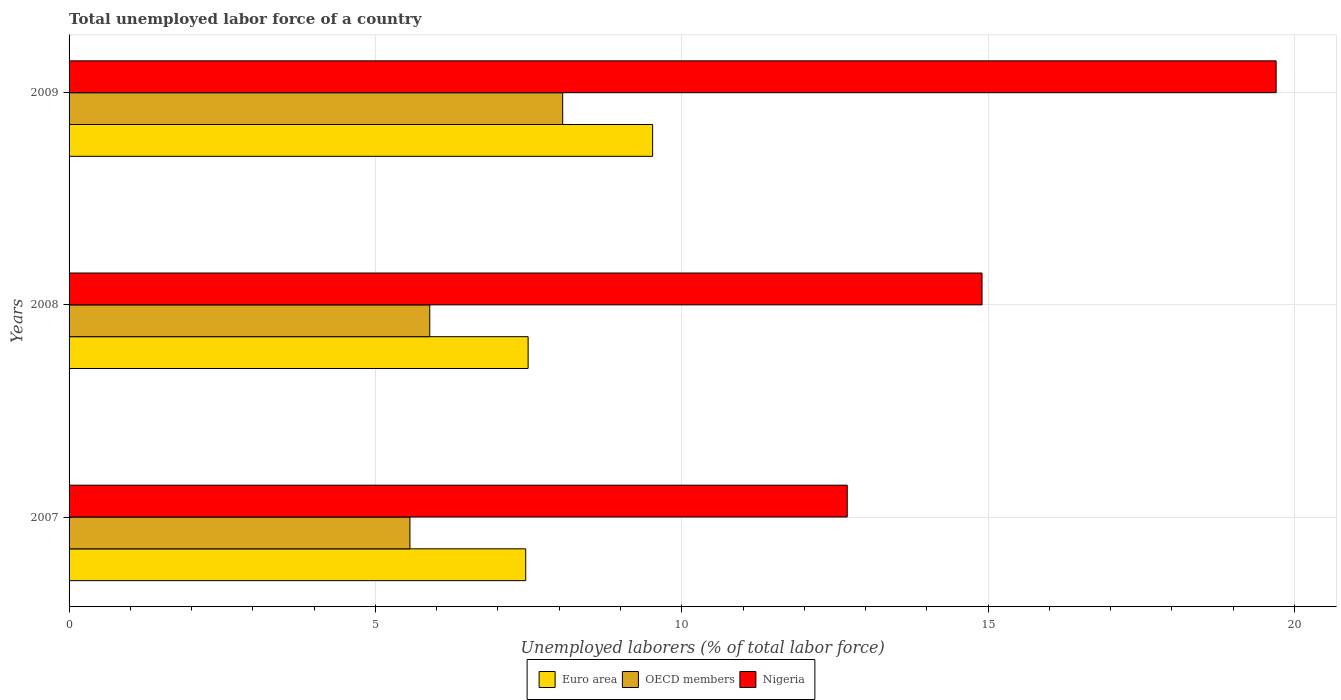How many different coloured bars are there?
Keep it short and to the point. 3. How many groups of bars are there?
Offer a terse response. 3. How many bars are there on the 1st tick from the top?
Your answer should be very brief. 3. How many bars are there on the 1st tick from the bottom?
Give a very brief answer. 3. In how many cases, is the number of bars for a given year not equal to the number of legend labels?
Make the answer very short. 0. What is the total unemployed labor force in OECD members in 2008?
Give a very brief answer. 5.89. Across all years, what is the maximum total unemployed labor force in Euro area?
Offer a very short reply. 9.52. Across all years, what is the minimum total unemployed labor force in OECD members?
Keep it short and to the point. 5.56. What is the total total unemployed labor force in Euro area in the graph?
Your answer should be compact. 24.47. What is the difference between the total unemployed labor force in Nigeria in 2007 and that in 2009?
Your answer should be very brief. -7. What is the difference between the total unemployed labor force in Euro area in 2009 and the total unemployed labor force in OECD members in 2007?
Provide a succinct answer. 3.96. What is the average total unemployed labor force in Nigeria per year?
Your answer should be very brief. 15.77. In the year 2007, what is the difference between the total unemployed labor force in Nigeria and total unemployed labor force in OECD members?
Your answer should be compact. 7.14. What is the ratio of the total unemployed labor force in OECD members in 2008 to that in 2009?
Keep it short and to the point. 0.73. Is the difference between the total unemployed labor force in Nigeria in 2007 and 2009 greater than the difference between the total unemployed labor force in OECD members in 2007 and 2009?
Provide a succinct answer. No. What is the difference between the highest and the second highest total unemployed labor force in Euro area?
Your answer should be compact. 2.03. What is the difference between the highest and the lowest total unemployed labor force in OECD members?
Ensure brevity in your answer.  2.49. In how many years, is the total unemployed labor force in Euro area greater than the average total unemployed labor force in Euro area taken over all years?
Provide a succinct answer. 1. What does the 1st bar from the top in 2007 represents?
Your answer should be very brief. Nigeria. What does the 2nd bar from the bottom in 2009 represents?
Provide a succinct answer. OECD members. How many bars are there?
Keep it short and to the point. 9. Are the values on the major ticks of X-axis written in scientific E-notation?
Provide a short and direct response. No. Does the graph contain any zero values?
Your answer should be very brief. No. Does the graph contain grids?
Offer a terse response. Yes. Where does the legend appear in the graph?
Keep it short and to the point. Bottom center. How many legend labels are there?
Make the answer very short. 3. What is the title of the graph?
Your response must be concise. Total unemployed labor force of a country. Does "Ghana" appear as one of the legend labels in the graph?
Ensure brevity in your answer.  No. What is the label or title of the X-axis?
Make the answer very short. Unemployed laborers (% of total labor force). What is the Unemployed laborers (% of total labor force) of Euro area in 2007?
Offer a terse response. 7.45. What is the Unemployed laborers (% of total labor force) in OECD members in 2007?
Your response must be concise. 5.56. What is the Unemployed laborers (% of total labor force) of Nigeria in 2007?
Provide a succinct answer. 12.7. What is the Unemployed laborers (% of total labor force) of Euro area in 2008?
Make the answer very short. 7.49. What is the Unemployed laborers (% of total labor force) of OECD members in 2008?
Your answer should be very brief. 5.89. What is the Unemployed laborers (% of total labor force) in Nigeria in 2008?
Your answer should be very brief. 14.9. What is the Unemployed laborers (% of total labor force) of Euro area in 2009?
Give a very brief answer. 9.52. What is the Unemployed laborers (% of total labor force) of OECD members in 2009?
Keep it short and to the point. 8.06. What is the Unemployed laborers (% of total labor force) of Nigeria in 2009?
Provide a succinct answer. 19.7. Across all years, what is the maximum Unemployed laborers (% of total labor force) in Euro area?
Keep it short and to the point. 9.52. Across all years, what is the maximum Unemployed laborers (% of total labor force) of OECD members?
Keep it short and to the point. 8.06. Across all years, what is the maximum Unemployed laborers (% of total labor force) of Nigeria?
Offer a very short reply. 19.7. Across all years, what is the minimum Unemployed laborers (% of total labor force) of Euro area?
Offer a very short reply. 7.45. Across all years, what is the minimum Unemployed laborers (% of total labor force) of OECD members?
Provide a short and direct response. 5.56. Across all years, what is the minimum Unemployed laborers (% of total labor force) of Nigeria?
Offer a very short reply. 12.7. What is the total Unemployed laborers (% of total labor force) of Euro area in the graph?
Provide a short and direct response. 24.47. What is the total Unemployed laborers (% of total labor force) in OECD members in the graph?
Your answer should be very brief. 19.51. What is the total Unemployed laborers (% of total labor force) in Nigeria in the graph?
Offer a terse response. 47.3. What is the difference between the Unemployed laborers (% of total labor force) of Euro area in 2007 and that in 2008?
Provide a succinct answer. -0.04. What is the difference between the Unemployed laborers (% of total labor force) of OECD members in 2007 and that in 2008?
Ensure brevity in your answer.  -0.32. What is the difference between the Unemployed laborers (% of total labor force) of Euro area in 2007 and that in 2009?
Give a very brief answer. -2.07. What is the difference between the Unemployed laborers (% of total labor force) of OECD members in 2007 and that in 2009?
Your answer should be very brief. -2.49. What is the difference between the Unemployed laborers (% of total labor force) of Euro area in 2008 and that in 2009?
Ensure brevity in your answer.  -2.03. What is the difference between the Unemployed laborers (% of total labor force) in OECD members in 2008 and that in 2009?
Your answer should be compact. -2.17. What is the difference between the Unemployed laborers (% of total labor force) in Euro area in 2007 and the Unemployed laborers (% of total labor force) in OECD members in 2008?
Your answer should be very brief. 1.57. What is the difference between the Unemployed laborers (% of total labor force) of Euro area in 2007 and the Unemployed laborers (% of total labor force) of Nigeria in 2008?
Keep it short and to the point. -7.45. What is the difference between the Unemployed laborers (% of total labor force) in OECD members in 2007 and the Unemployed laborers (% of total labor force) in Nigeria in 2008?
Your response must be concise. -9.34. What is the difference between the Unemployed laborers (% of total labor force) of Euro area in 2007 and the Unemployed laborers (% of total labor force) of OECD members in 2009?
Provide a short and direct response. -0.6. What is the difference between the Unemployed laborers (% of total labor force) of Euro area in 2007 and the Unemployed laborers (% of total labor force) of Nigeria in 2009?
Provide a succinct answer. -12.25. What is the difference between the Unemployed laborers (% of total labor force) in OECD members in 2007 and the Unemployed laborers (% of total labor force) in Nigeria in 2009?
Offer a terse response. -14.14. What is the difference between the Unemployed laborers (% of total labor force) of Euro area in 2008 and the Unemployed laborers (% of total labor force) of OECD members in 2009?
Make the answer very short. -0.56. What is the difference between the Unemployed laborers (% of total labor force) of Euro area in 2008 and the Unemployed laborers (% of total labor force) of Nigeria in 2009?
Offer a terse response. -12.21. What is the difference between the Unemployed laborers (% of total labor force) in OECD members in 2008 and the Unemployed laborers (% of total labor force) in Nigeria in 2009?
Offer a terse response. -13.81. What is the average Unemployed laborers (% of total labor force) of Euro area per year?
Your answer should be very brief. 8.16. What is the average Unemployed laborers (% of total labor force) of OECD members per year?
Make the answer very short. 6.5. What is the average Unemployed laborers (% of total labor force) in Nigeria per year?
Provide a short and direct response. 15.77. In the year 2007, what is the difference between the Unemployed laborers (% of total labor force) in Euro area and Unemployed laborers (% of total labor force) in OECD members?
Your answer should be very brief. 1.89. In the year 2007, what is the difference between the Unemployed laborers (% of total labor force) in Euro area and Unemployed laborers (% of total labor force) in Nigeria?
Give a very brief answer. -5.25. In the year 2007, what is the difference between the Unemployed laborers (% of total labor force) of OECD members and Unemployed laborers (% of total labor force) of Nigeria?
Provide a succinct answer. -7.14. In the year 2008, what is the difference between the Unemployed laborers (% of total labor force) in Euro area and Unemployed laborers (% of total labor force) in OECD members?
Ensure brevity in your answer.  1.61. In the year 2008, what is the difference between the Unemployed laborers (% of total labor force) in Euro area and Unemployed laborers (% of total labor force) in Nigeria?
Ensure brevity in your answer.  -7.41. In the year 2008, what is the difference between the Unemployed laborers (% of total labor force) of OECD members and Unemployed laborers (% of total labor force) of Nigeria?
Keep it short and to the point. -9.01. In the year 2009, what is the difference between the Unemployed laborers (% of total labor force) of Euro area and Unemployed laborers (% of total labor force) of OECD members?
Ensure brevity in your answer.  1.47. In the year 2009, what is the difference between the Unemployed laborers (% of total labor force) in Euro area and Unemployed laborers (% of total labor force) in Nigeria?
Give a very brief answer. -10.18. In the year 2009, what is the difference between the Unemployed laborers (% of total labor force) in OECD members and Unemployed laborers (% of total labor force) in Nigeria?
Make the answer very short. -11.64. What is the ratio of the Unemployed laborers (% of total labor force) in Euro area in 2007 to that in 2008?
Ensure brevity in your answer.  0.99. What is the ratio of the Unemployed laborers (% of total labor force) of OECD members in 2007 to that in 2008?
Offer a very short reply. 0.95. What is the ratio of the Unemployed laborers (% of total labor force) in Nigeria in 2007 to that in 2008?
Give a very brief answer. 0.85. What is the ratio of the Unemployed laborers (% of total labor force) in Euro area in 2007 to that in 2009?
Make the answer very short. 0.78. What is the ratio of the Unemployed laborers (% of total labor force) in OECD members in 2007 to that in 2009?
Make the answer very short. 0.69. What is the ratio of the Unemployed laborers (% of total labor force) of Nigeria in 2007 to that in 2009?
Offer a very short reply. 0.64. What is the ratio of the Unemployed laborers (% of total labor force) of Euro area in 2008 to that in 2009?
Give a very brief answer. 0.79. What is the ratio of the Unemployed laborers (% of total labor force) in OECD members in 2008 to that in 2009?
Ensure brevity in your answer.  0.73. What is the ratio of the Unemployed laborers (% of total labor force) in Nigeria in 2008 to that in 2009?
Give a very brief answer. 0.76. What is the difference between the highest and the second highest Unemployed laborers (% of total labor force) of Euro area?
Keep it short and to the point. 2.03. What is the difference between the highest and the second highest Unemployed laborers (% of total labor force) in OECD members?
Your answer should be compact. 2.17. What is the difference between the highest and the lowest Unemployed laborers (% of total labor force) in Euro area?
Ensure brevity in your answer.  2.07. What is the difference between the highest and the lowest Unemployed laborers (% of total labor force) in OECD members?
Offer a very short reply. 2.49. What is the difference between the highest and the lowest Unemployed laborers (% of total labor force) in Nigeria?
Your response must be concise. 7. 